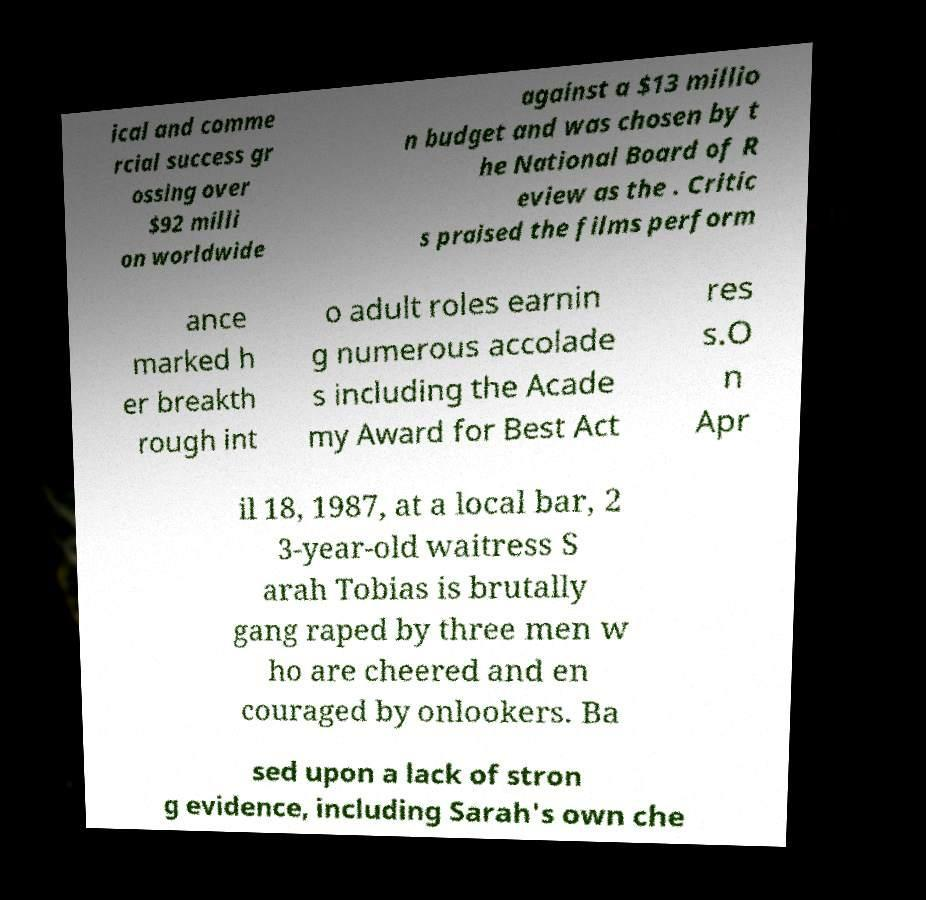Please identify and transcribe the text found in this image. ical and comme rcial success gr ossing over $92 milli on worldwide against a $13 millio n budget and was chosen by t he National Board of R eview as the . Critic s praised the films perform ance marked h er breakth rough int o adult roles earnin g numerous accolade s including the Acade my Award for Best Act res s.O n Apr il 18, 1987, at a local bar, 2 3-year-old waitress S arah Tobias is brutally gang raped by three men w ho are cheered and en couraged by onlookers. Ba sed upon a lack of stron g evidence, including Sarah's own che 